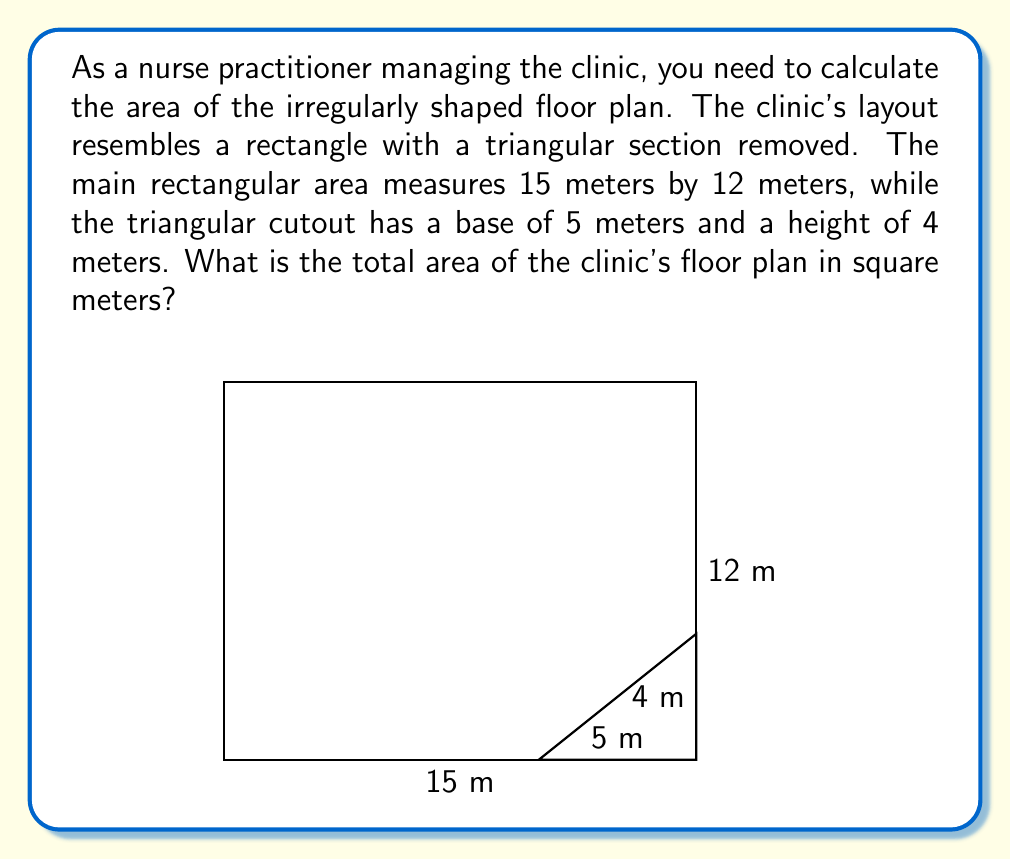What is the answer to this math problem? To calculate the area of the irregularly shaped clinic floor plan, we need to follow these steps:

1. Calculate the area of the full rectangle:
   $$A_{rectangle} = length \times width = 15 \text{ m} \times 12 \text{ m} = 180 \text{ m}^2$$

2. Calculate the area of the triangular cutout:
   $$A_{triangle} = \frac{1}{2} \times base \times height = \frac{1}{2} \times 5 \text{ m} \times 4 \text{ m} = 10 \text{ m}^2$$

3. Subtract the area of the triangular cutout from the full rectangle:
   $$A_{clinic} = A_{rectangle} - A_{triangle} = 180 \text{ m}^2 - 10 \text{ m}^2 = 170 \text{ m}^2$$

Therefore, the total area of the clinic's floor plan is 170 square meters.
Answer: 170 m² 